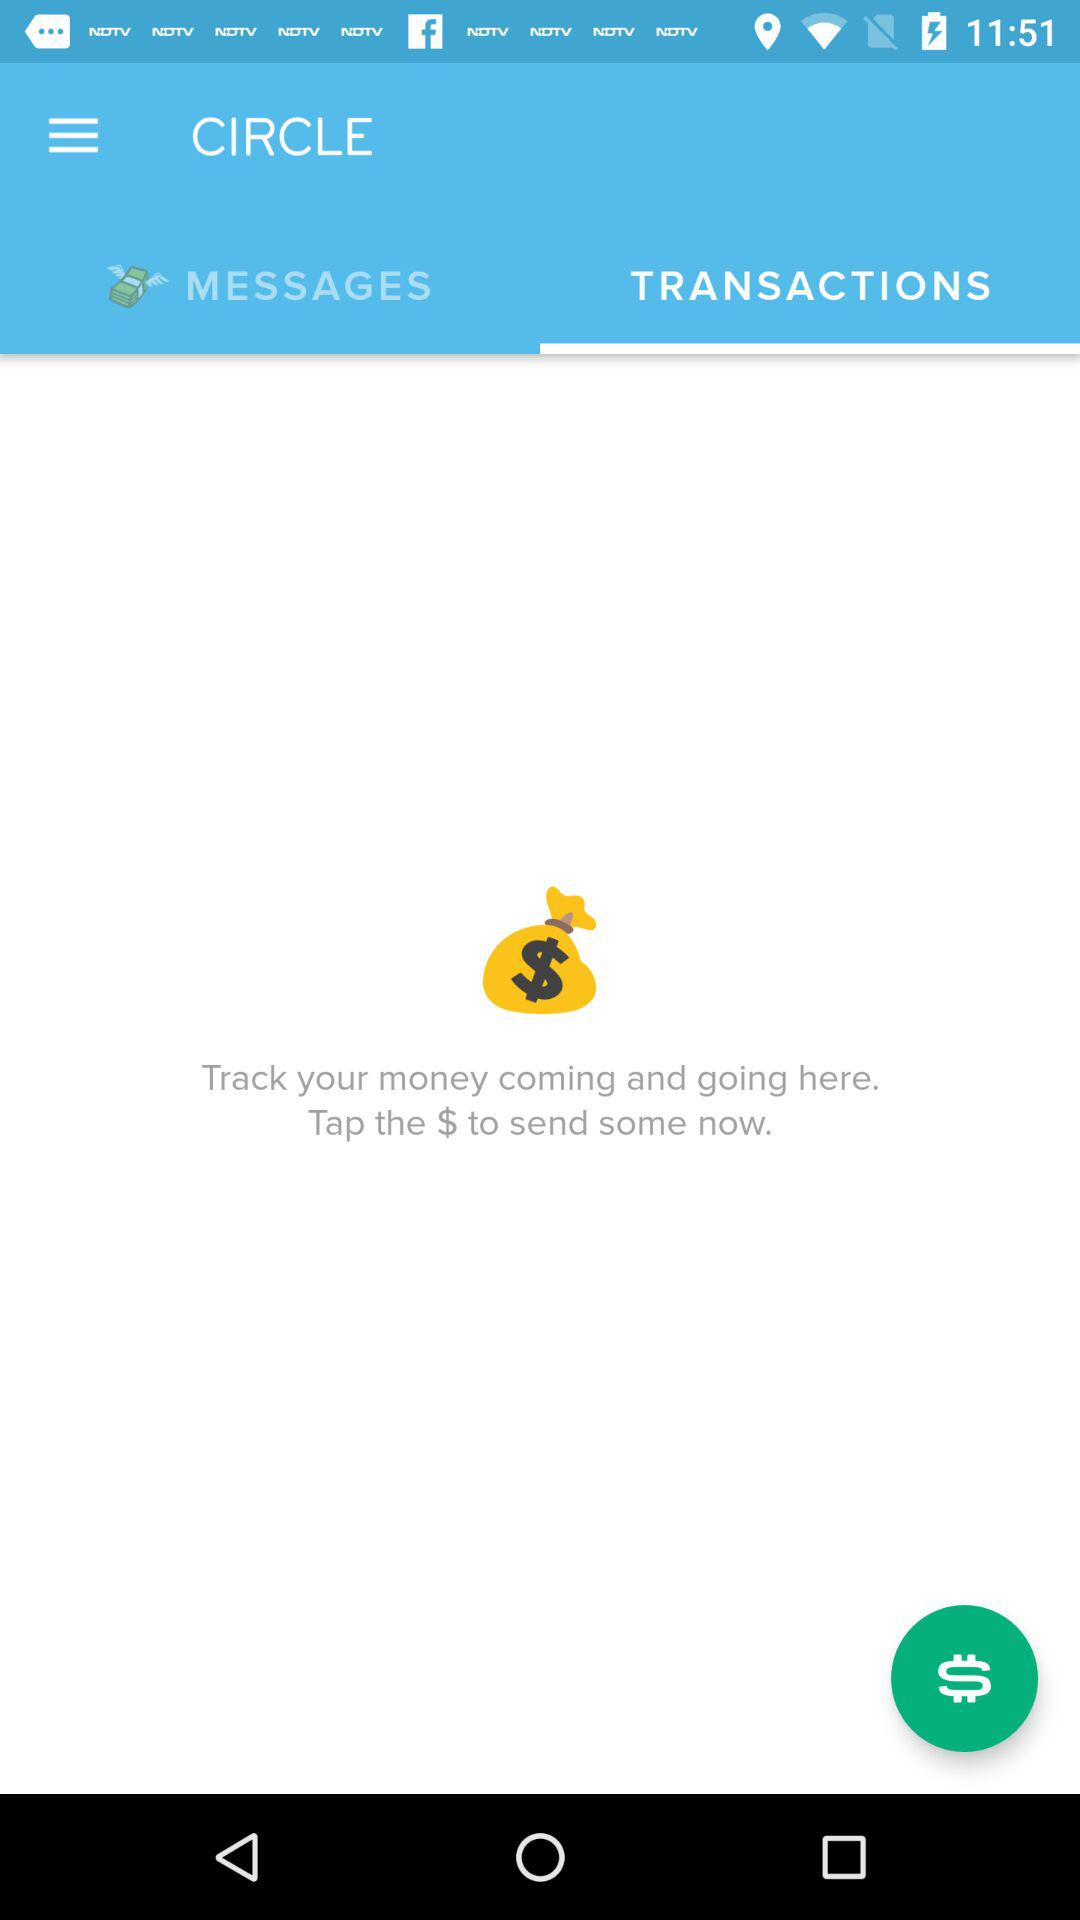What is the name of the application? The name of the application is "CIRCLE". 